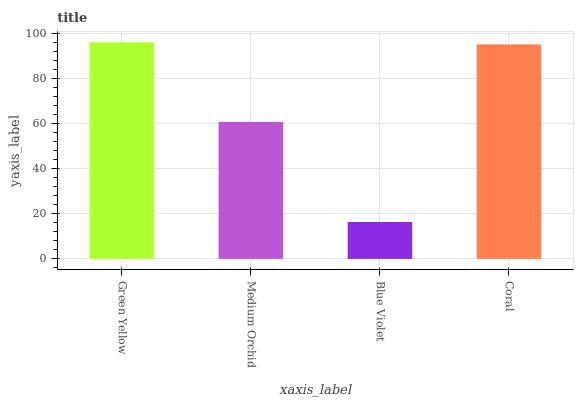Is Blue Violet the minimum?
Answer yes or no. Yes. Is Green Yellow the maximum?
Answer yes or no. Yes. Is Medium Orchid the minimum?
Answer yes or no. No. Is Medium Orchid the maximum?
Answer yes or no. No. Is Green Yellow greater than Medium Orchid?
Answer yes or no. Yes. Is Medium Orchid less than Green Yellow?
Answer yes or no. Yes. Is Medium Orchid greater than Green Yellow?
Answer yes or no. No. Is Green Yellow less than Medium Orchid?
Answer yes or no. No. Is Coral the high median?
Answer yes or no. Yes. Is Medium Orchid the low median?
Answer yes or no. Yes. Is Blue Violet the high median?
Answer yes or no. No. Is Coral the low median?
Answer yes or no. No. 